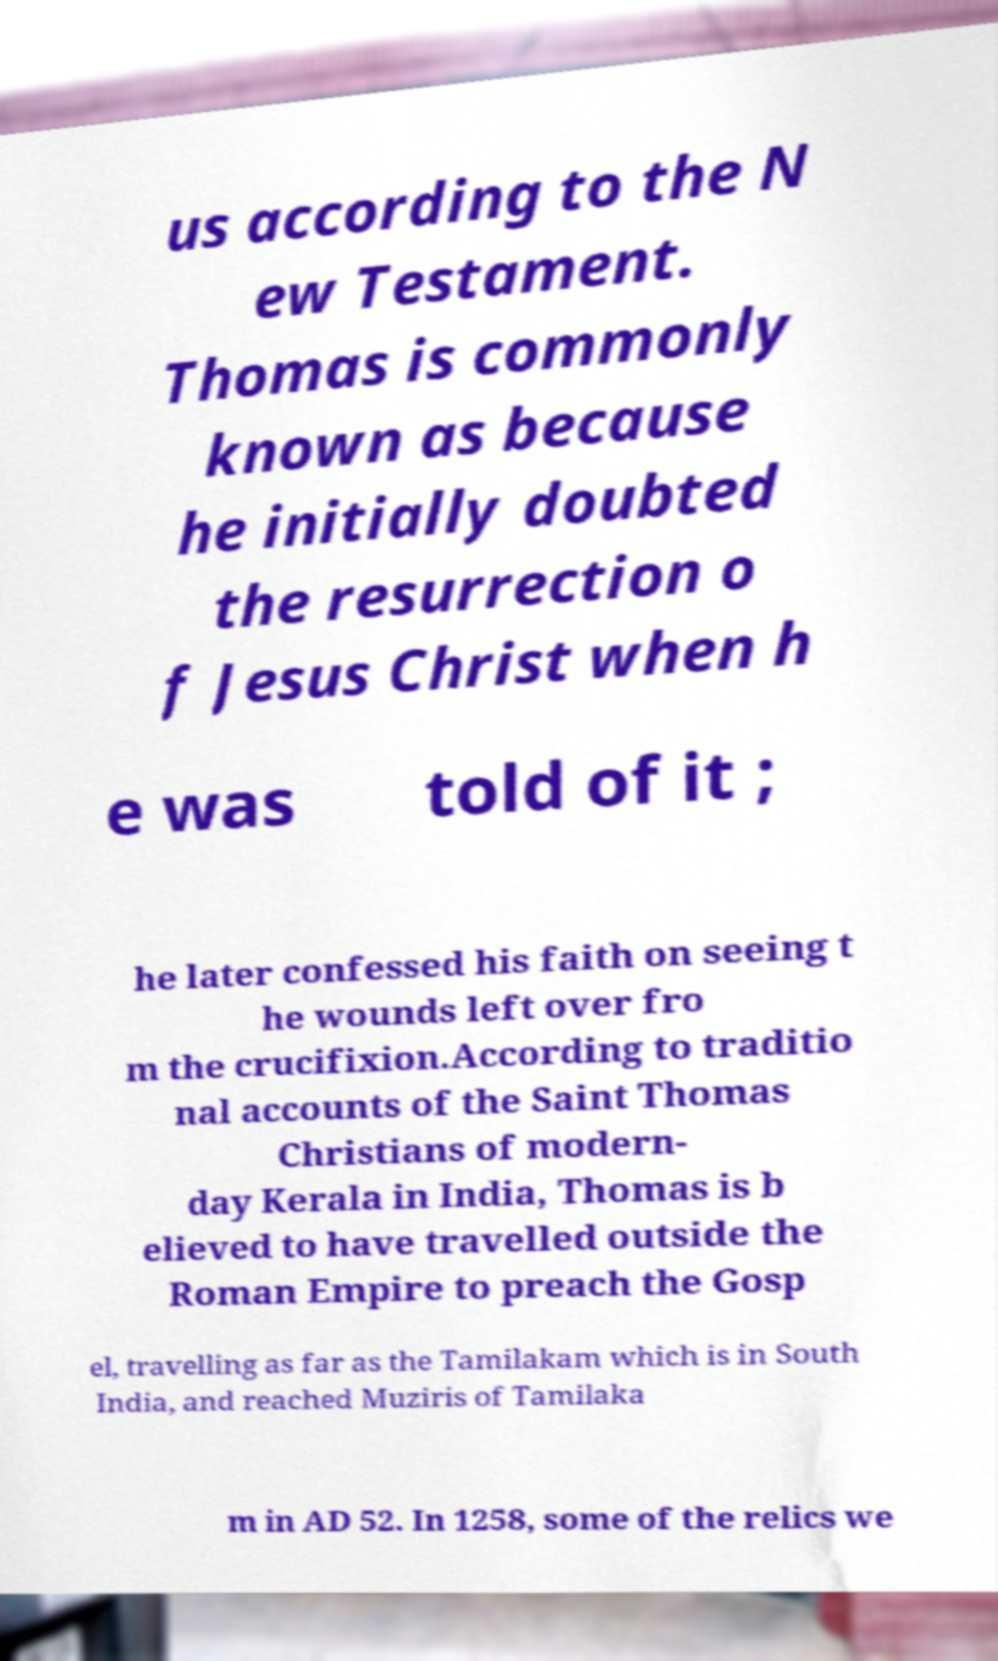Can you accurately transcribe the text from the provided image for me? us according to the N ew Testament. Thomas is commonly known as because he initially doubted the resurrection o f Jesus Christ when h e was told of it ; he later confessed his faith on seeing t he wounds left over fro m the crucifixion.According to traditio nal accounts of the Saint Thomas Christians of modern- day Kerala in India, Thomas is b elieved to have travelled outside the Roman Empire to preach the Gosp el, travelling as far as the Tamilakam which is in South India, and reached Muziris of Tamilaka m in AD 52. In 1258, some of the relics we 